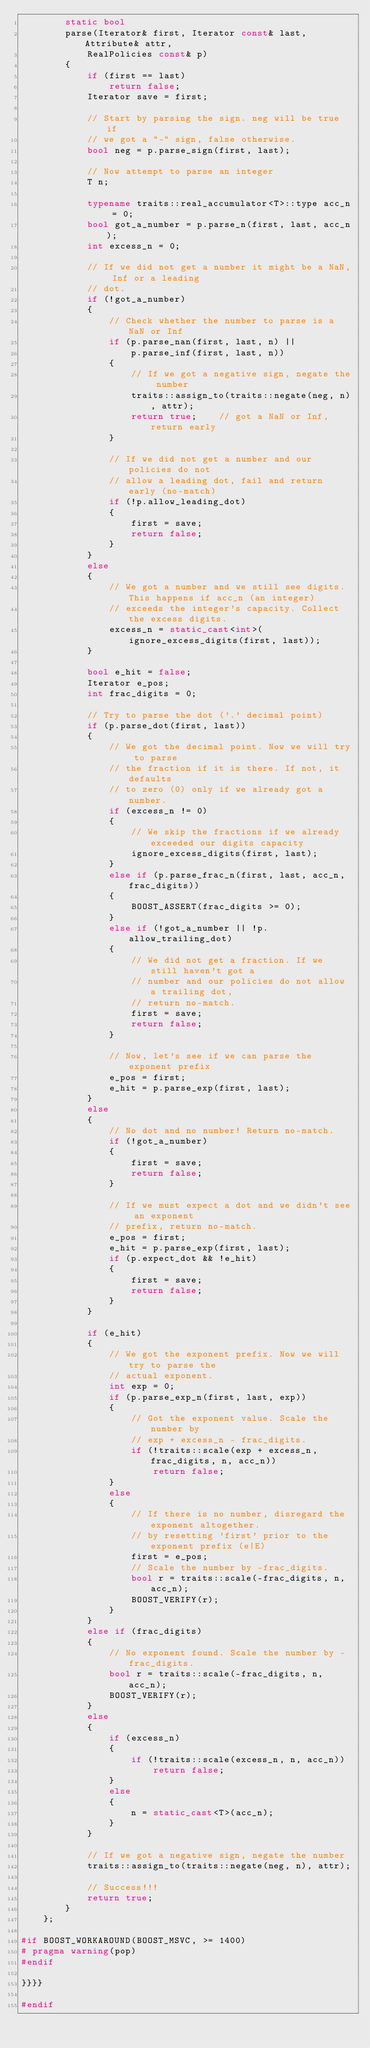Convert code to text. <code><loc_0><loc_0><loc_500><loc_500><_C++_>        static bool
        parse(Iterator& first, Iterator const& last, Attribute& attr,
            RealPolicies const& p)
        {
            if (first == last)
                return false;
            Iterator save = first;

            // Start by parsing the sign. neg will be true if
            // we got a "-" sign, false otherwise.
            bool neg = p.parse_sign(first, last);

            // Now attempt to parse an integer
            T n;

            typename traits::real_accumulator<T>::type acc_n = 0;
            bool got_a_number = p.parse_n(first, last, acc_n);
            int excess_n = 0;

            // If we did not get a number it might be a NaN, Inf or a leading
            // dot.
            if (!got_a_number)
            {
                // Check whether the number to parse is a NaN or Inf
                if (p.parse_nan(first, last, n) ||
                    p.parse_inf(first, last, n))
                {
                    // If we got a negative sign, negate the number
                    traits::assign_to(traits::negate(neg, n), attr);
                    return true;    // got a NaN or Inf, return early
                }

                // If we did not get a number and our policies do not
                // allow a leading dot, fail and return early (no-match)
                if (!p.allow_leading_dot)
                {
                    first = save;
                    return false;
                }
            }
            else
            {
                // We got a number and we still see digits. This happens if acc_n (an integer)
                // exceeds the integer's capacity. Collect the excess digits.
                excess_n = static_cast<int>(ignore_excess_digits(first, last));
            }

            bool e_hit = false;
            Iterator e_pos;
            int frac_digits = 0;

            // Try to parse the dot ('.' decimal point)
            if (p.parse_dot(first, last))
            {
                // We got the decimal point. Now we will try to parse
                // the fraction if it is there. If not, it defaults
                // to zero (0) only if we already got a number.
                if (excess_n != 0)
                {
                    // We skip the fractions if we already exceeded our digits capacity
                    ignore_excess_digits(first, last);
                }
                else if (p.parse_frac_n(first, last, acc_n, frac_digits))
                {
                    BOOST_ASSERT(frac_digits >= 0);
                }
                else if (!got_a_number || !p.allow_trailing_dot)
                {
                    // We did not get a fraction. If we still haven't got a
                    // number and our policies do not allow a trailing dot,
                    // return no-match.
                    first = save;
                    return false;
                }

                // Now, let's see if we can parse the exponent prefix
                e_pos = first;
                e_hit = p.parse_exp(first, last);
            }
            else
            {
                // No dot and no number! Return no-match.
                if (!got_a_number)
                {
                    first = save;
                    return false;
                }

                // If we must expect a dot and we didn't see an exponent
                // prefix, return no-match.
                e_pos = first;
                e_hit = p.parse_exp(first, last);
                if (p.expect_dot && !e_hit)
                {
                    first = save;
                    return false;
                }
            }

            if (e_hit)
            {
                // We got the exponent prefix. Now we will try to parse the
                // actual exponent.
                int exp = 0;
                if (p.parse_exp_n(first, last, exp))
                {
                    // Got the exponent value. Scale the number by
                    // exp + excess_n - frac_digits.
                    if (!traits::scale(exp + excess_n, frac_digits, n, acc_n))
                        return false;
                }
                else
                {
                    // If there is no number, disregard the exponent altogether.
                    // by resetting 'first' prior to the exponent prefix (e|E)
                    first = e_pos;
                    // Scale the number by -frac_digits.
                    bool r = traits::scale(-frac_digits, n, acc_n);
                    BOOST_VERIFY(r);
                }
            }
            else if (frac_digits)
            {
                // No exponent found. Scale the number by -frac_digits.
                bool r = traits::scale(-frac_digits, n, acc_n);
                BOOST_VERIFY(r);
            }
            else
            {
                if (excess_n)
                {
                    if (!traits::scale(excess_n, n, acc_n))
                        return false;
                }
                else
                {
                    n = static_cast<T>(acc_n);
                }
            }

            // If we got a negative sign, negate the number
            traits::assign_to(traits::negate(neg, n), attr);

            // Success!!!
            return true;
        }
    };

#if BOOST_WORKAROUND(BOOST_MSVC, >= 1400)
# pragma warning(pop)
#endif

}}}}

#endif
</code> 